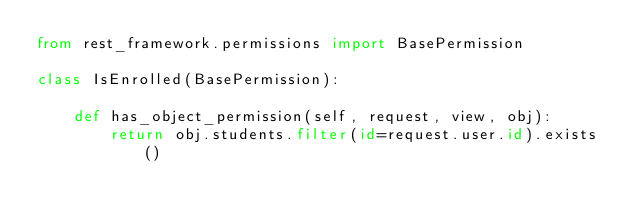<code> <loc_0><loc_0><loc_500><loc_500><_Python_>from rest_framework.permissions import BasePermission

class IsEnrolled(BasePermission):

    def has_object_permission(self, request, view, obj):
        return obj.students.filter(id=request.user.id).exists()</code> 